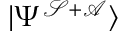<formula> <loc_0><loc_0><loc_500><loc_500>| \Psi ^ { \mathcal { S + A } } \rangle</formula> 